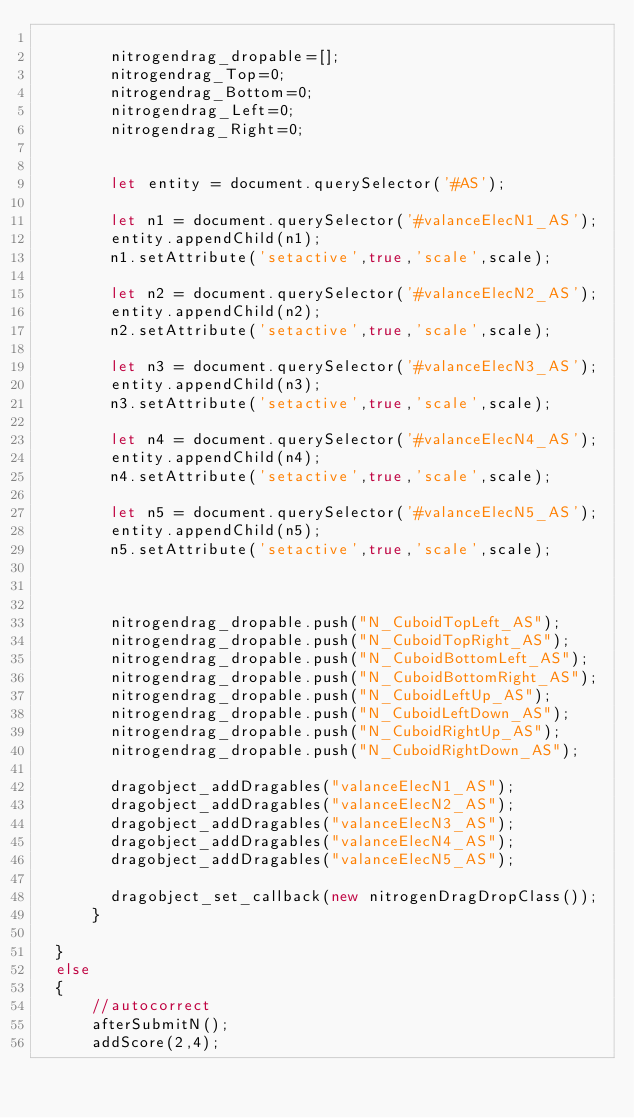Convert code to text. <code><loc_0><loc_0><loc_500><loc_500><_JavaScript_>
        nitrogendrag_dropable=[];
        nitrogendrag_Top=0;
        nitrogendrag_Bottom=0;
        nitrogendrag_Left=0;
        nitrogendrag_Right=0;


        let entity = document.querySelector('#AS');

        let n1 = document.querySelector('#valanceElecN1_AS');
        entity.appendChild(n1);
        n1.setAttribute('setactive',true,'scale',scale);

        let n2 = document.querySelector('#valanceElecN2_AS');
        entity.appendChild(n2);
        n2.setAttribute('setactive',true,'scale',scale);

        let n3 = document.querySelector('#valanceElecN3_AS');
        entity.appendChild(n3);
        n3.setAttribute('setactive',true,'scale',scale);

        let n4 = document.querySelector('#valanceElecN4_AS');
        entity.appendChild(n4);
        n4.setAttribute('setactive',true,'scale',scale);

        let n5 = document.querySelector('#valanceElecN5_AS');
        entity.appendChild(n5);
        n5.setAttribute('setactive',true,'scale',scale);



        nitrogendrag_dropable.push("N_CuboidTopLeft_AS");
        nitrogendrag_dropable.push("N_CuboidTopRight_AS");
        nitrogendrag_dropable.push("N_CuboidBottomLeft_AS");
        nitrogendrag_dropable.push("N_CuboidBottomRight_AS");
        nitrogendrag_dropable.push("N_CuboidLeftUp_AS");
        nitrogendrag_dropable.push("N_CuboidLeftDown_AS");
        nitrogendrag_dropable.push("N_CuboidRightUp_AS");
        nitrogendrag_dropable.push("N_CuboidRightDown_AS");

        dragobject_addDragables("valanceElecN1_AS");
        dragobject_addDragables("valanceElecN2_AS");
        dragobject_addDragables("valanceElecN3_AS");
        dragobject_addDragables("valanceElecN4_AS");
        dragobject_addDragables("valanceElecN5_AS");

        dragobject_set_callback(new nitrogenDragDropClass());
      }

  }
  else
  {
      //autocorrect
      afterSubmitN();
      addScore(2,4);</code> 